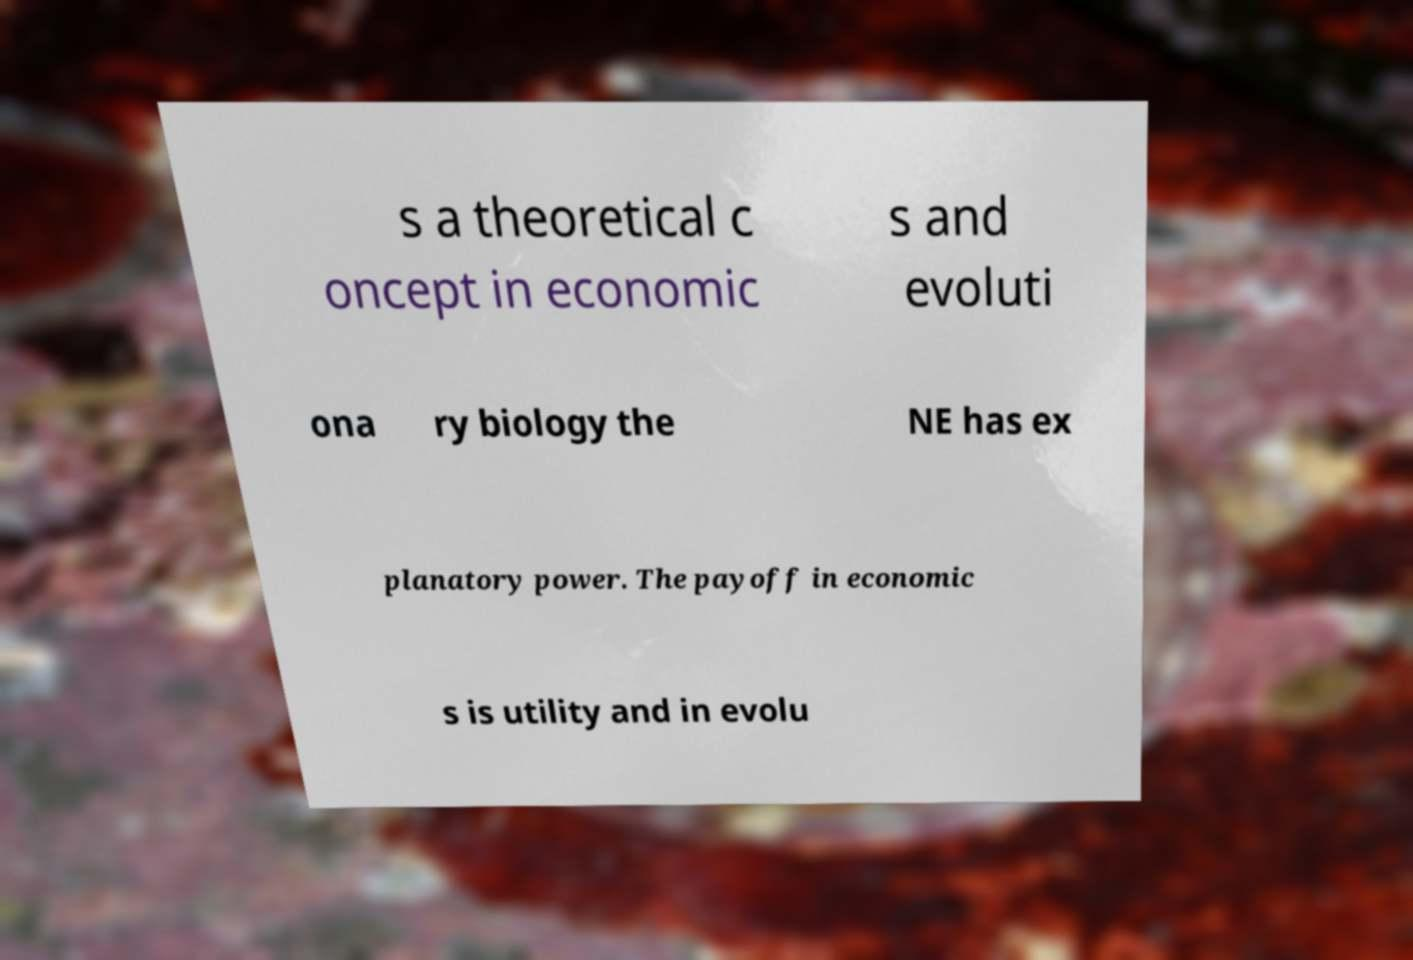Can you read and provide the text displayed in the image?This photo seems to have some interesting text. Can you extract and type it out for me? s a theoretical c oncept in economic s and evoluti ona ry biology the NE has ex planatory power. The payoff in economic s is utility and in evolu 